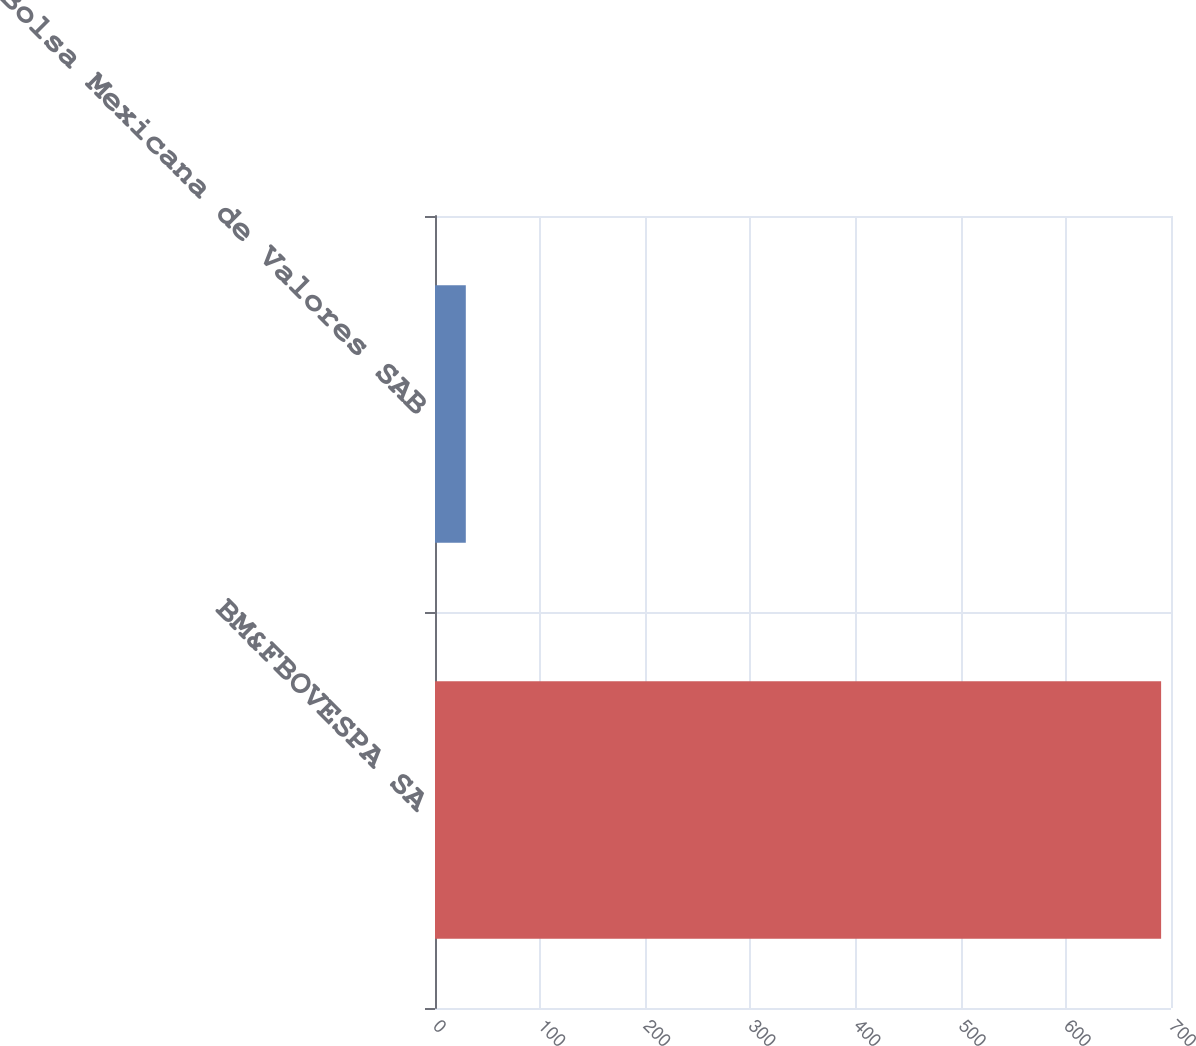Convert chart. <chart><loc_0><loc_0><loc_500><loc_500><bar_chart><fcel>BM&FBOVESPA SA<fcel>Bolsa Mexicana de Valores SAB<nl><fcel>690.6<fcel>29.3<nl></chart> 